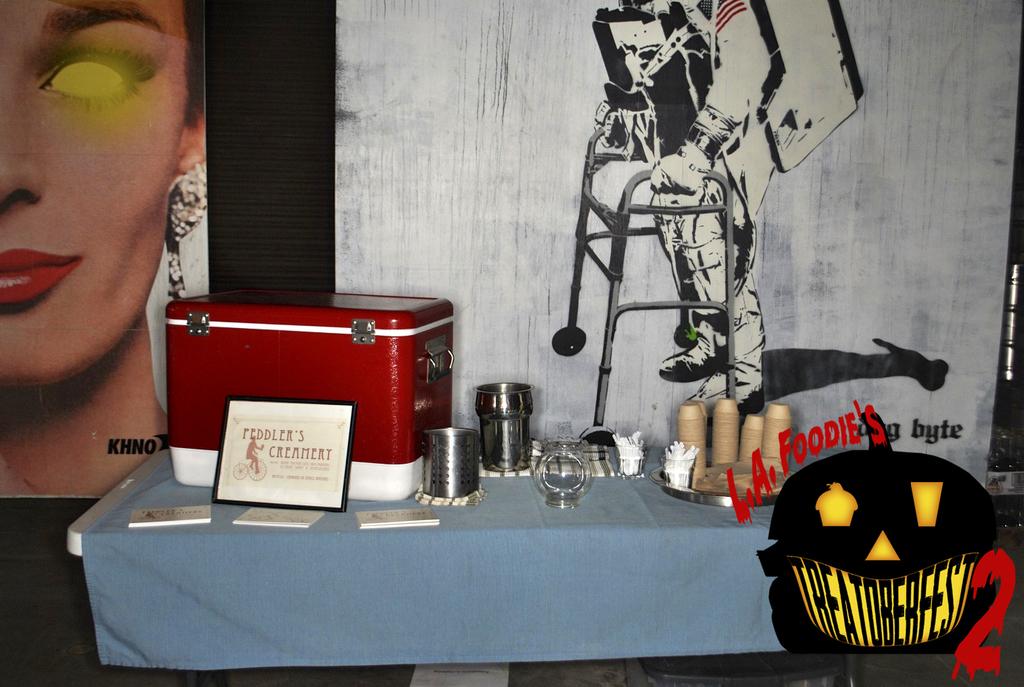What word is on the jack-o-lantern?
Ensure brevity in your answer.  Treatoberfest. What creamery is shown on the sign on the table?
Your answer should be compact. Peddler's. 